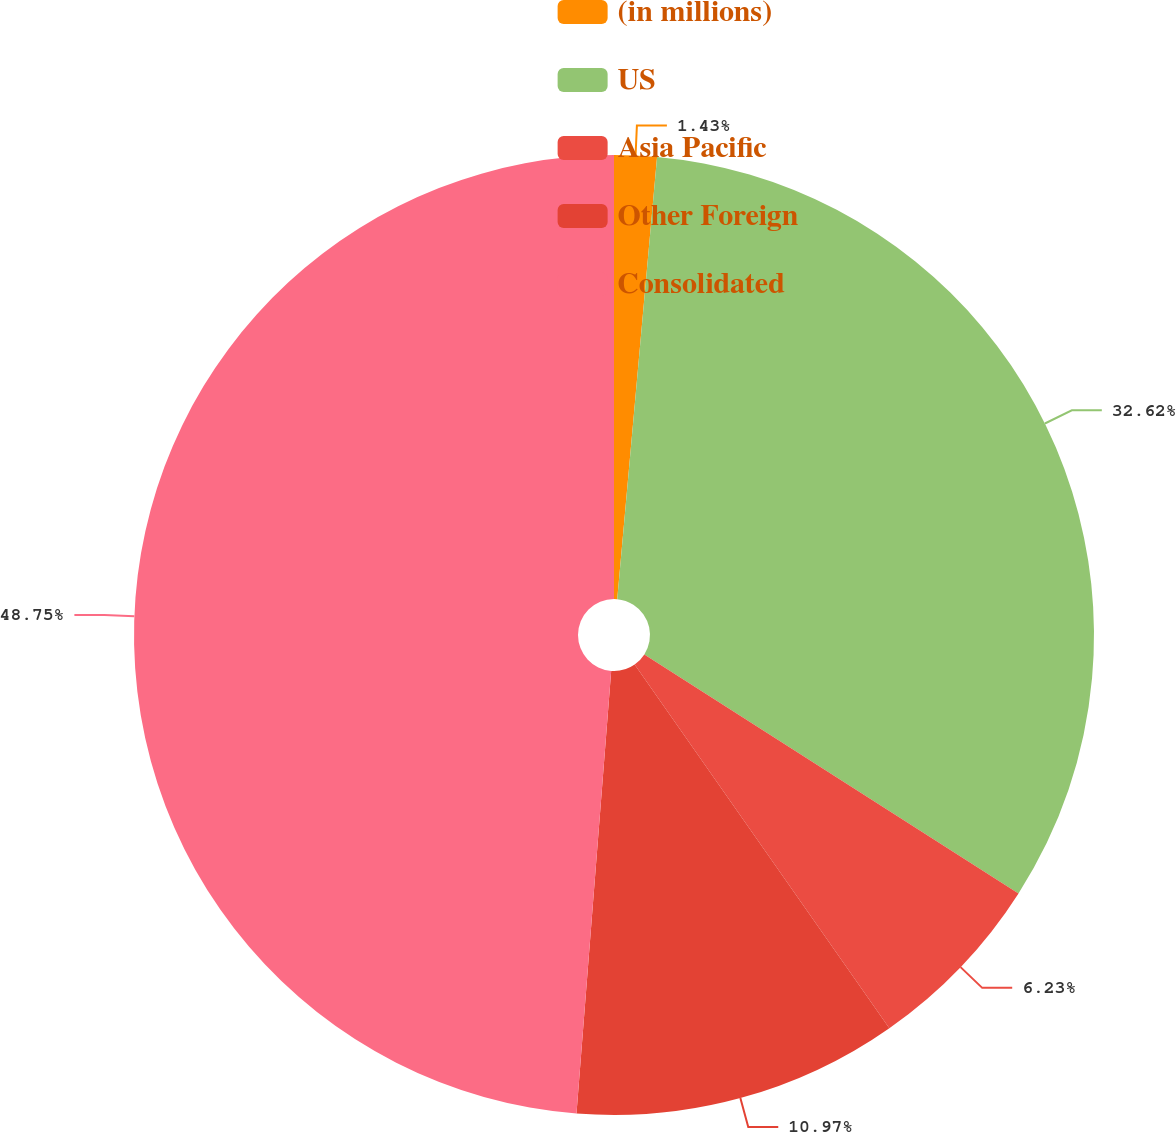<chart> <loc_0><loc_0><loc_500><loc_500><pie_chart><fcel>(in millions)<fcel>US<fcel>Asia Pacific<fcel>Other Foreign<fcel>Consolidated<nl><fcel>1.43%<fcel>32.62%<fcel>6.23%<fcel>10.97%<fcel>48.76%<nl></chart> 